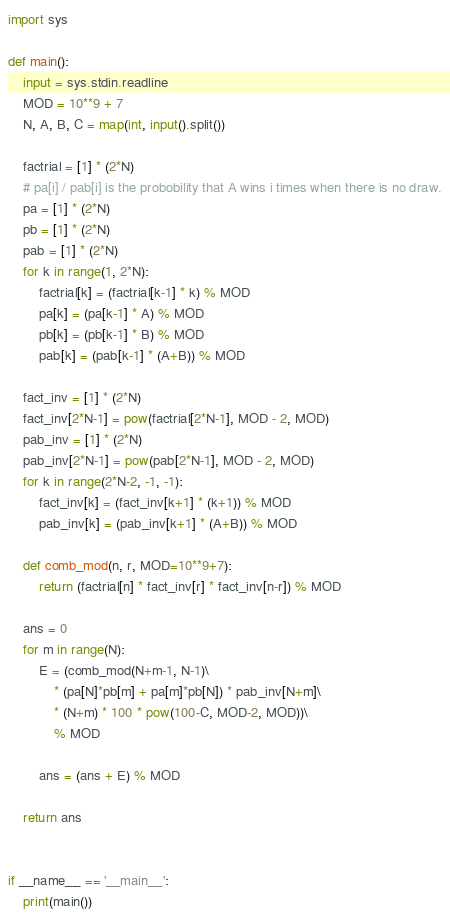Convert code to text. <code><loc_0><loc_0><loc_500><loc_500><_Python_>import sys

def main():
    input = sys.stdin.readline
    MOD = 10**9 + 7
    N, A, B, C = map(int, input().split())

    factrial = [1] * (2*N)
    # pa[i] / pab[i] is the probobility that A wins i times when there is no draw.
    pa = [1] * (2*N)
    pb = [1] * (2*N)
    pab = [1] * (2*N)
    for k in range(1, 2*N):
        factrial[k] = (factrial[k-1] * k) % MOD
        pa[k] = (pa[k-1] * A) % MOD
        pb[k] = (pb[k-1] * B) % MOD
        pab[k] = (pab[k-1] * (A+B)) % MOD
    
    fact_inv = [1] * (2*N)
    fact_inv[2*N-1] = pow(factrial[2*N-1], MOD - 2, MOD)
    pab_inv = [1] * (2*N)
    pab_inv[2*N-1] = pow(pab[2*N-1], MOD - 2, MOD)
    for k in range(2*N-2, -1, -1):
        fact_inv[k] = (fact_inv[k+1] * (k+1)) % MOD
        pab_inv[k] = (pab_inv[k+1] * (A+B)) % MOD
 
    def comb_mod(n, r, MOD=10**9+7):
        return (factrial[n] * fact_inv[r] * fact_inv[n-r]) % MOD

    ans = 0
    for m in range(N):
        E = (comb_mod(N+m-1, N-1)\
            * (pa[N]*pb[m] + pa[m]*pb[N]) * pab_inv[N+m]\
            * (N+m) * 100 * pow(100-C, MOD-2, MOD))\
            % MOD

        ans = (ans + E) % MOD

    return ans


if __name__ == '__main__':
    print(main())
</code> 